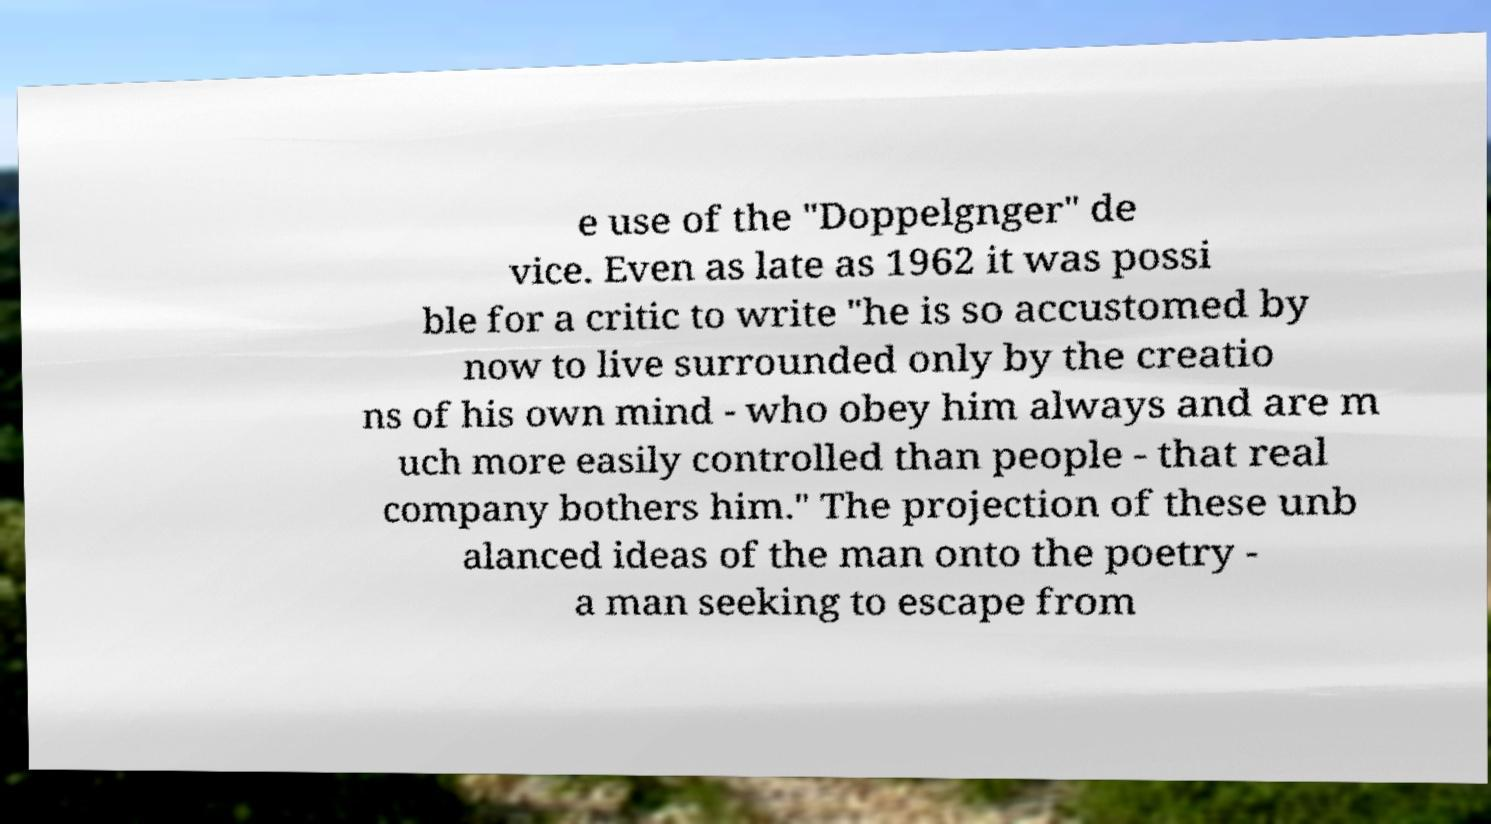What messages or text are displayed in this image? I need them in a readable, typed format. e use of the "Doppelgnger" de vice. Even as late as 1962 it was possi ble for a critic to write "he is so accustomed by now to live surrounded only by the creatio ns of his own mind - who obey him always and are m uch more easily controlled than people - that real company bothers him." The projection of these unb alanced ideas of the man onto the poetry - a man seeking to escape from 